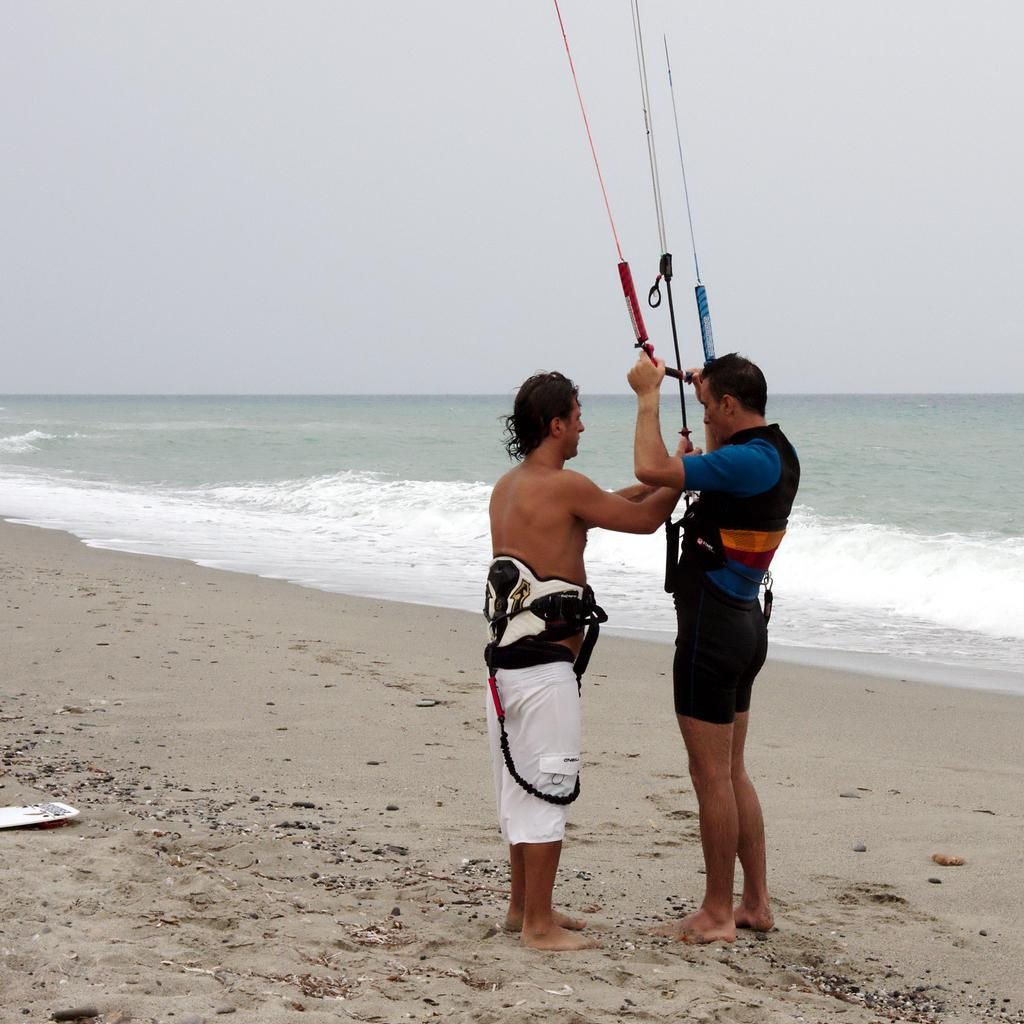How many people are in the image? There are two men in the image. What is the surface the men are standing on? The men are standing on a sand surface. What can be seen in the background of the image? There is a sea and the sky visible in the background of the image. What channel are the men watching in the image? There is no television or channel present in the image; the men are standing on a sand surface near the sea. 